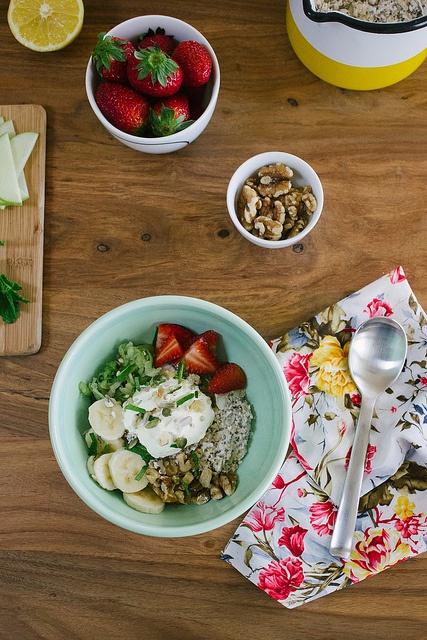Describe the objects in this image and their specific colors. I can see dining table in maroon, olive, darkgray, and lightgray tones, bowl in black, darkgray, lightgray, lightblue, and teal tones, bowl in black, maroon, darkgray, and brown tones, bowl in black, lightgray, olive, and maroon tones, and spoon in black, darkgray, lightgray, and gray tones in this image. 